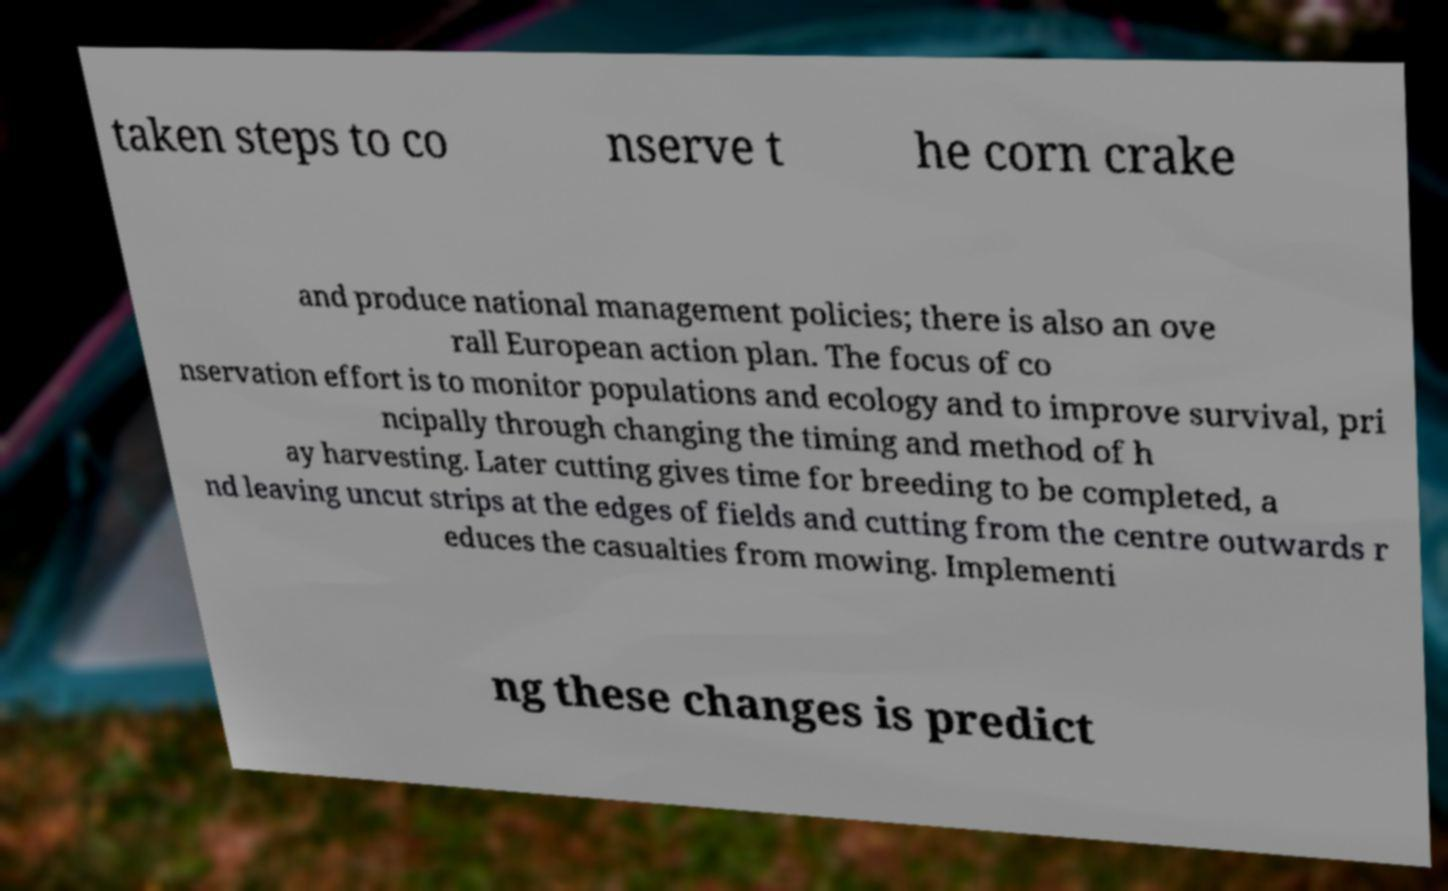Could you assist in decoding the text presented in this image and type it out clearly? taken steps to co nserve t he corn crake and produce national management policies; there is also an ove rall European action plan. The focus of co nservation effort is to monitor populations and ecology and to improve survival, pri ncipally through changing the timing and method of h ay harvesting. Later cutting gives time for breeding to be completed, a nd leaving uncut strips at the edges of fields and cutting from the centre outwards r educes the casualties from mowing. Implementi ng these changes is predict 